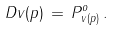<formula> <loc_0><loc_0><loc_500><loc_500>D v ( p ) \, = \, P ^ { o } _ { v ( p ) } \, .</formula> 